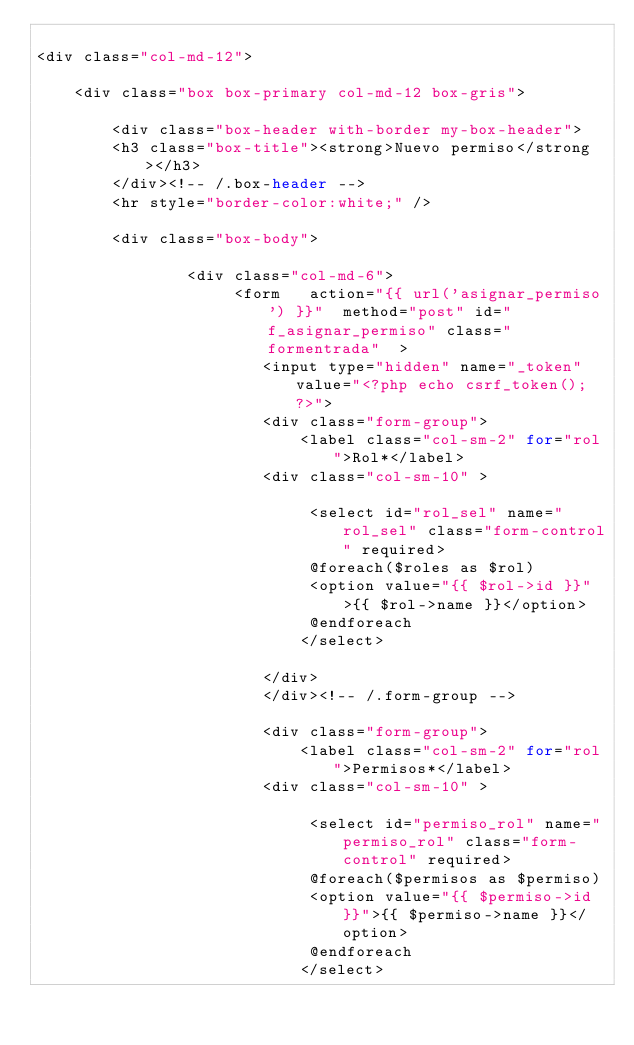<code> <loc_0><loc_0><loc_500><loc_500><_PHP_>
<div class="col-md-12">

    <div class="box box-primary col-md-12 box-gris">
 
        <div class="box-header with-border my-box-header">
        <h3 class="box-title"><strong>Nuevo permiso</strong></h3>
        </div><!-- /.box-header -->
        <hr style="border-color:white;" />
 
        <div class="box-body">

                <div class="col-md-6">
		             <form   action="{{ url('asignar_permiso') }}"  method="post" id="f_asignar_permiso" class="formentrada"  >
						<input type="hidden" name="_token" value="<?php echo csrf_token(); ?>"> 
						<div class="form-group">
							<label class="col-sm-2" for="rol">Rol*</label>
		    			<div class="col-sm-10" >
		                     
		                     <select id="rol_sel" name="rol_sel" class="form-control" required>
		                     @foreach($roles as $rol)
		                     <option value="{{ $rol->id }}">{{ $rol->name }}</option>
		                     @endforeach
		    				</select>
		                     
		                </div>
						</div><!-- /.form-group -->

						<div class="form-group">
							<label class="col-sm-2" for="rol">Permisos*</label>
		    			<div class="col-sm-10" >
		                     
		                     <select id="permiso_rol" name="permiso_rol" class="form-control" required>
		                     @foreach($permisos as $permiso)
		                     <option value="{{ $permiso->id }}">{{ $permiso->name }}</option>
		                     @endforeach
		    				</select>
		                     </code> 